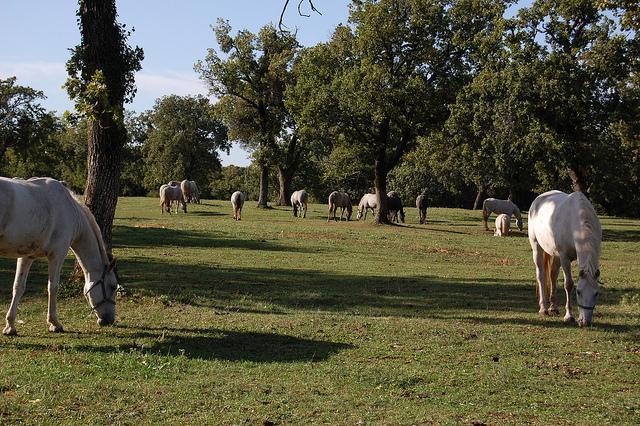What animals are present?
Indicate the correct response and explain using: 'Answer: answer
Rationale: rationale.'
Options: Giraffe, deer, dog, horse. Answer: horse.
Rationale: The animal is a horse. 